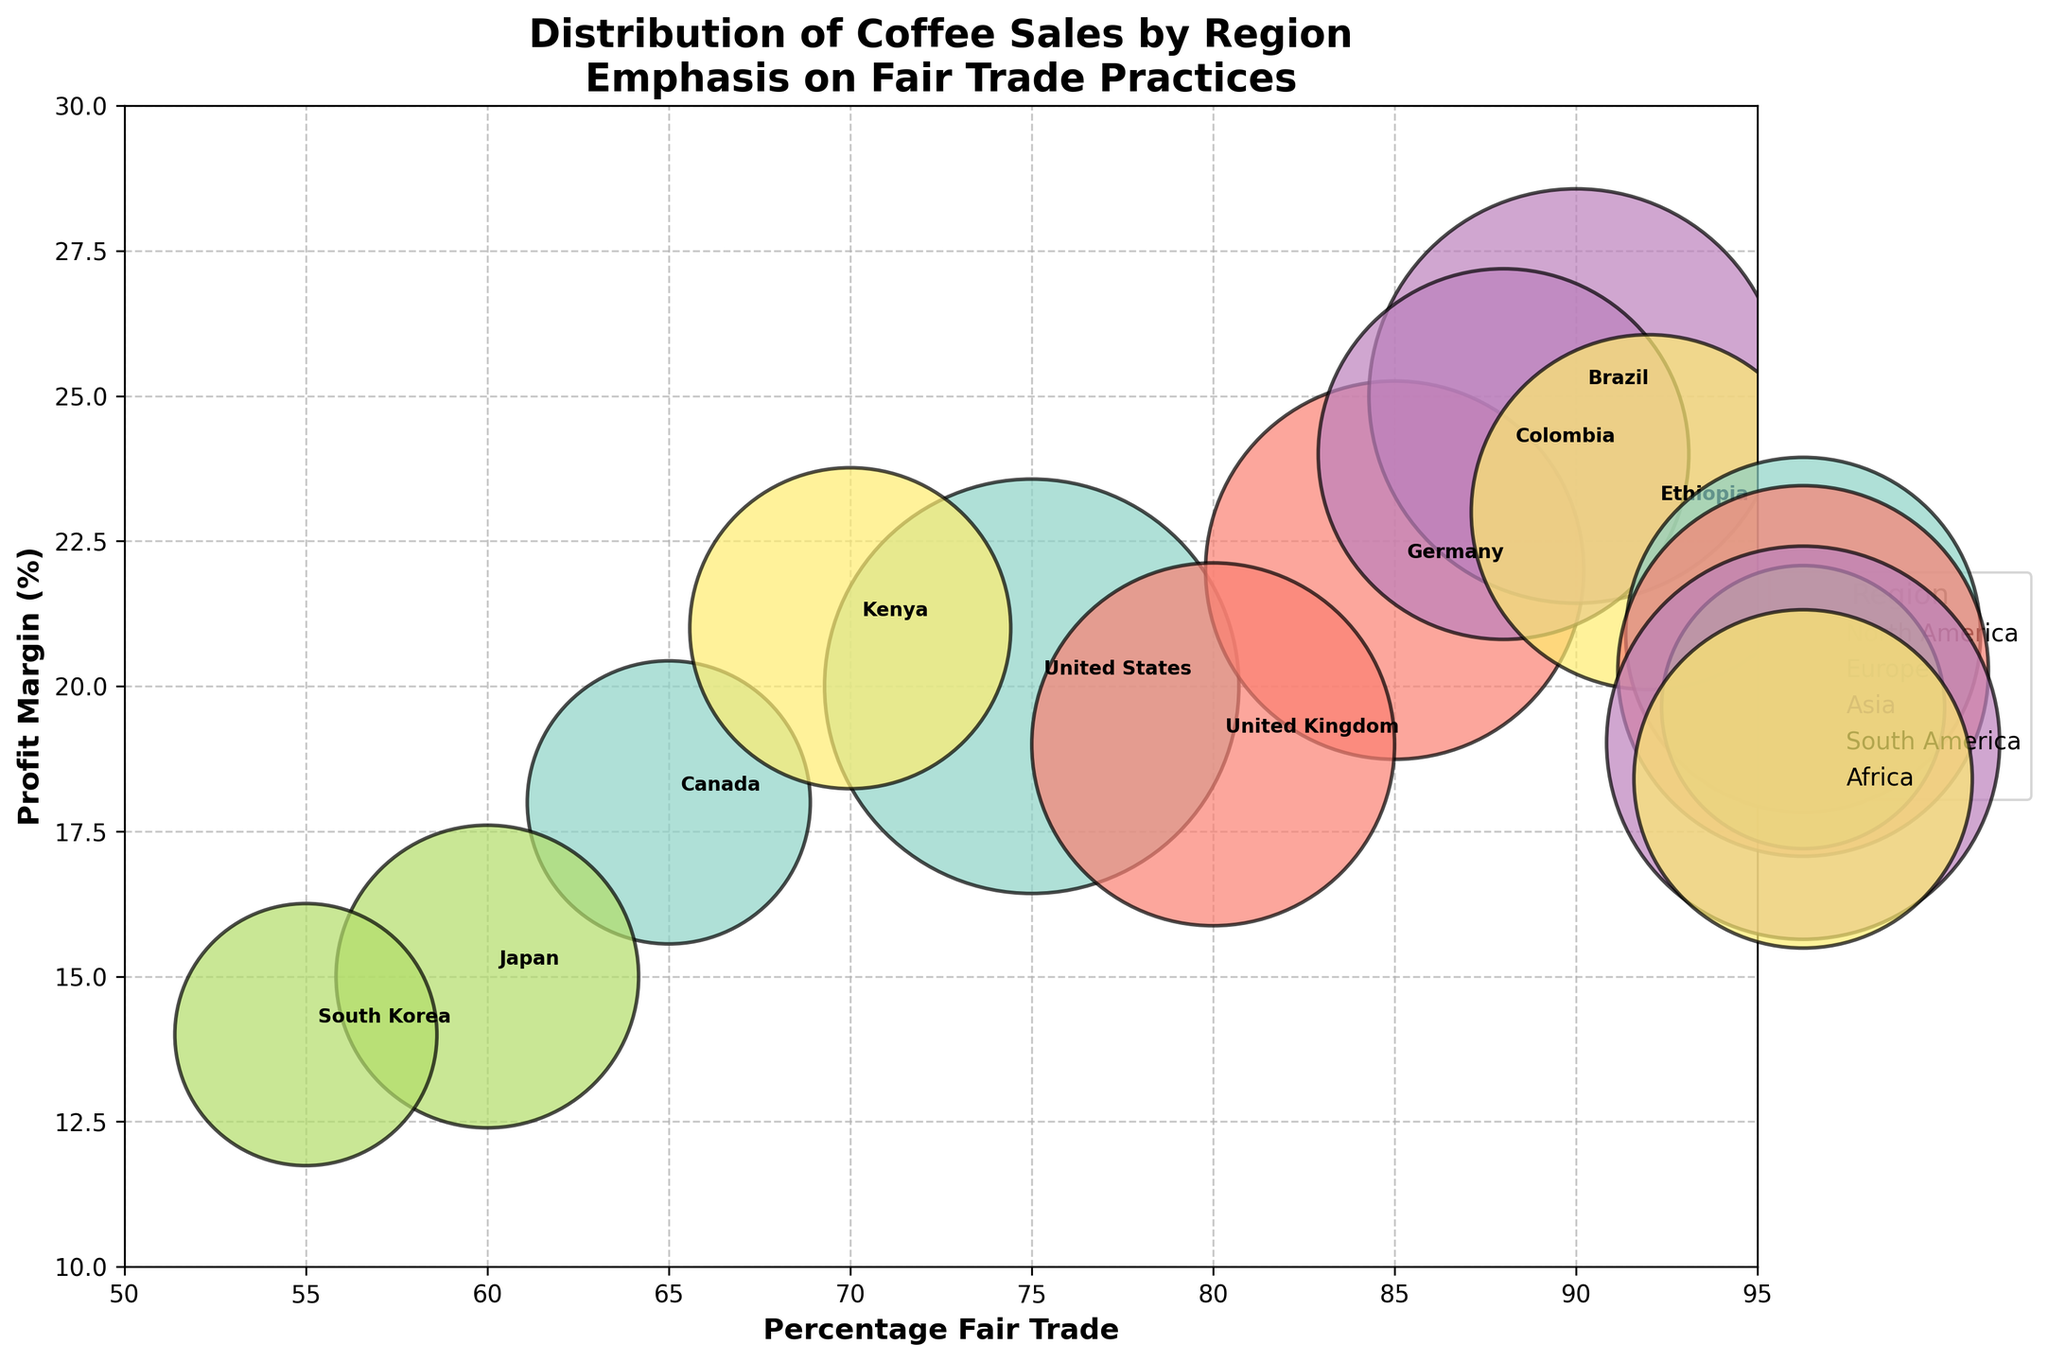What's the title of the chart? The title of the chart is usually located at the top of the figure. It is designed to give a summary of what the plot represents. In this case, it's "Distribution of Coffee Sales by Region" with an emphasis on Fair Trade practices.
Answer: Distribution of Coffee Sales by Region What are the x-axis and y-axis labels? The x-axis label is on the bottom of the figure, representing the percentage of Fair Trade, while the y-axis label is on the left side, representing the profit margin percentage. These labels provide context for what the axes represent.
Answer: Percentage Fair Trade, Profit Margin (%) How many regions are represented in the chart? Each region is identified by a distinct color and has a corresponding label in the legend. By counting the entries in the legend, you can determine the number of regions.
Answer: 5 Which country has the highest percentage of Fair Trade practices? To find this, look along the x-axis for the point that is furthest to the right. The associated label will tell you the country.
Answer: Ethiopia Which region has the country with the highest profit margin? To determine this, look for the highest point on the y-axis and check its color. Then match this color with the legend to find the region.
Answer: South America (Brazil) Compare the sales volume between the United States and Japan. Which one is higher? Sales volume information for each country can be compared from the bubble sizes. By comparing the sizes of the bubbles corresponding to the United States and Japan, it's clear which one is larger.
Answer: United States What is the average profit margin for all the countries displayed? To find the average profit margin, sum up all the profit margins and divide by the number of countries. That's (20 + 18 + 22 + 19 + 15 + 14 + 25 + 24 + 23 + 21) / 10.
Answer: 20.1% How many countries have more than 70% of their sales as Fair Trade? By looking at the x-axis, identify and count the number of points that have values greater than 70%. Those points represent countries with more than 70% Fair Trade sales.
Answer: 6 Which country has the smallest bubble size and what does it represent? The smallest bubble size represents the lowest sales volume. By comparing the sizes of bubbles, identify the smallest one and refer to its associated country.
Answer: South Korea For Europe, what is the difference in profit margin between Germany and the United Kingdom? Locate the bubbles for Germany and the United Kingdom. Note their positions on the y-axis. Subtract the United Kingdom's profit margin from Germany's to find the difference.
Answer: 3 